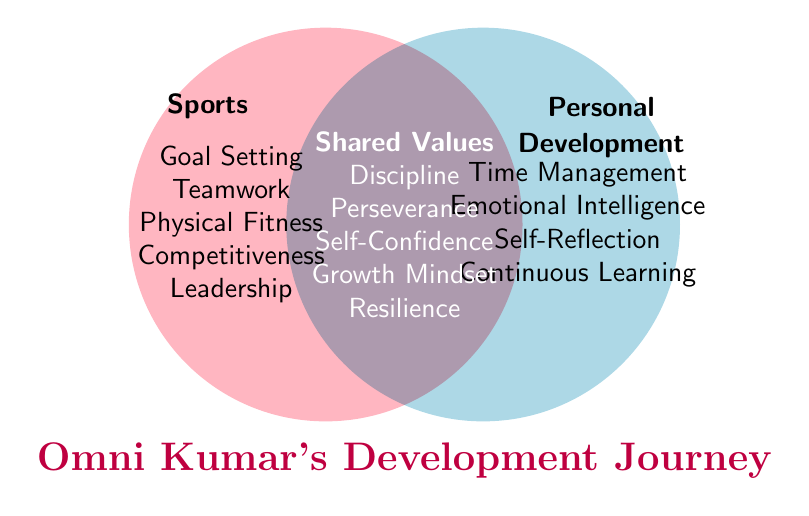What is the title of the Venn Diagram? The title is typically located at the top or bottom of the figure, highlighting the main theme of the diagram. Here, it is placed below the overlapping circles.
Answer: Omni Kumar's Development Journey Which values are exclusive to Sports? By looking at the section only under “Sports,” you can see the exclusive values listed.
Answer: Goal Setting, Teamwork, Physical Fitness, Competitiveness, Leadership Which values are common to both Sports and Personal Development? The shared segment of the Venn Diagram lists these values in the overlapping area.
Answer: Discipline, Perseverance, Self-Confidence, Growth Mindset, Resilience How many values are exclusive to Personal Development? Count the distinct values in the section only under “Personal Development.”
Answer: Four Are there more values exclusive to Sports or Personal Development? Compare the number of values in the Sports and Personal Development sections. Sports has five exclusive values, while Personal Development has four.
Answer: Sports Which value is listed first under Personal Development? In the Personal Development section, the first listed item is what you're looking for.
Answer: Time Management Name a shared value that reflects the ability to withstand pressure or adversity. In the shared segment, find a value synonymous with withstanding pressure or adversity.
Answer: Resilience How many total values are there in the Venn Diagram including shared values? Add the number of exclusive values in Sports, Personal Development, and the shared values together.
Answer: 14 Which value directly contributes to understanding and managing emotions under Personal Development? Find the value related to emotions in the Personal Development section.
Answer: Emotional Intelligence 